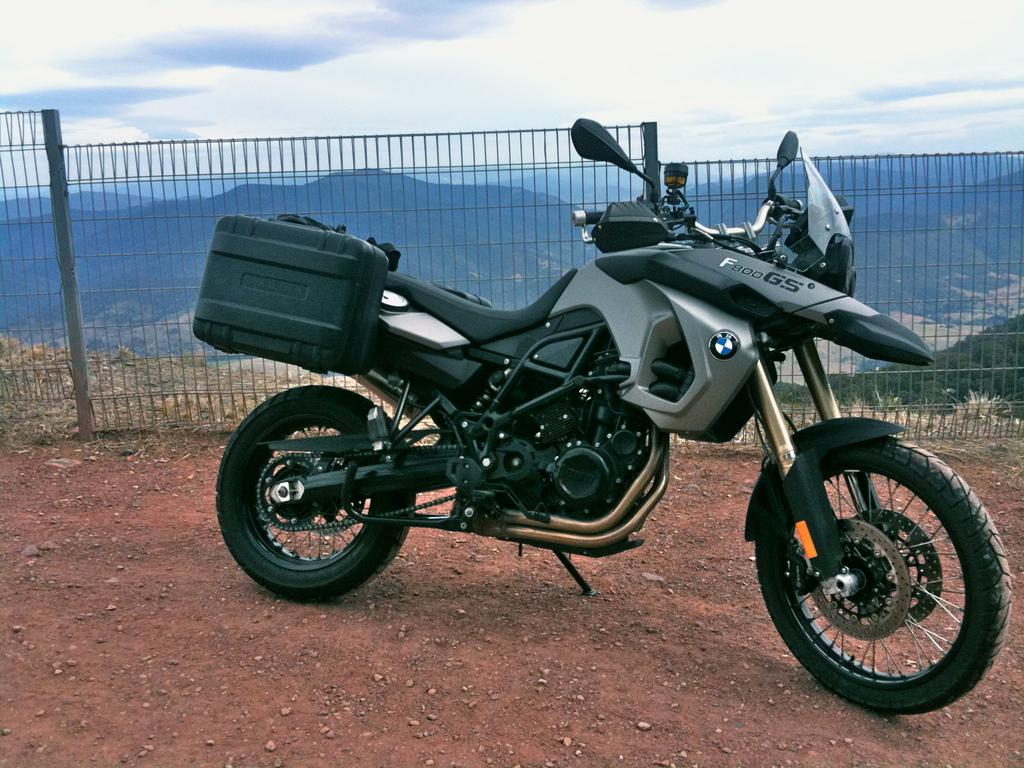What is the main subject of the image? The main subject of the image is a bike. Can you describe the bike in the image? The bike is black in color. What can be seen in the background of the image? In the background of the image, there is sky, clouds, hills, a fence, and a few other objects. What type of invention is being demonstrated in the image? There is no invention being demonstrated in the image; it features a black bike in the center and various background elements. Can you tell me how many notebooks are visible in the image? There are no notebooks present in the image. 